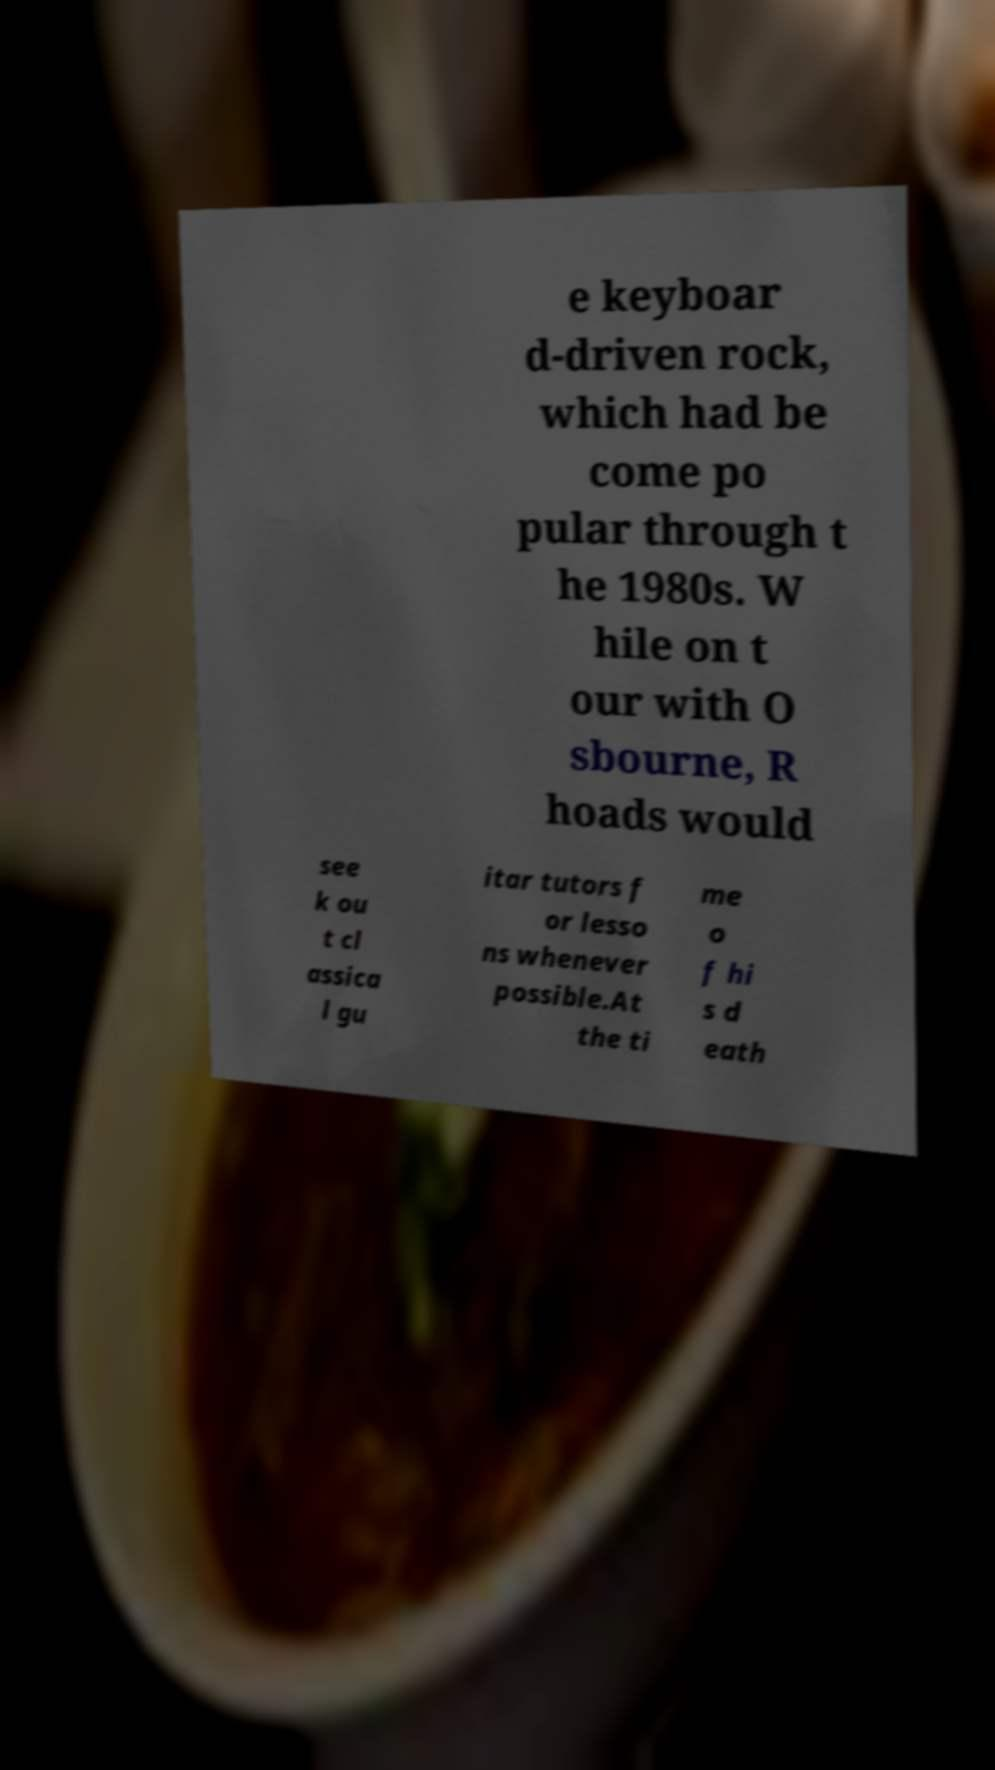What messages or text are displayed in this image? I need them in a readable, typed format. e keyboar d-driven rock, which had be come po pular through t he 1980s. W hile on t our with O sbourne, R hoads would see k ou t cl assica l gu itar tutors f or lesso ns whenever possible.At the ti me o f hi s d eath 